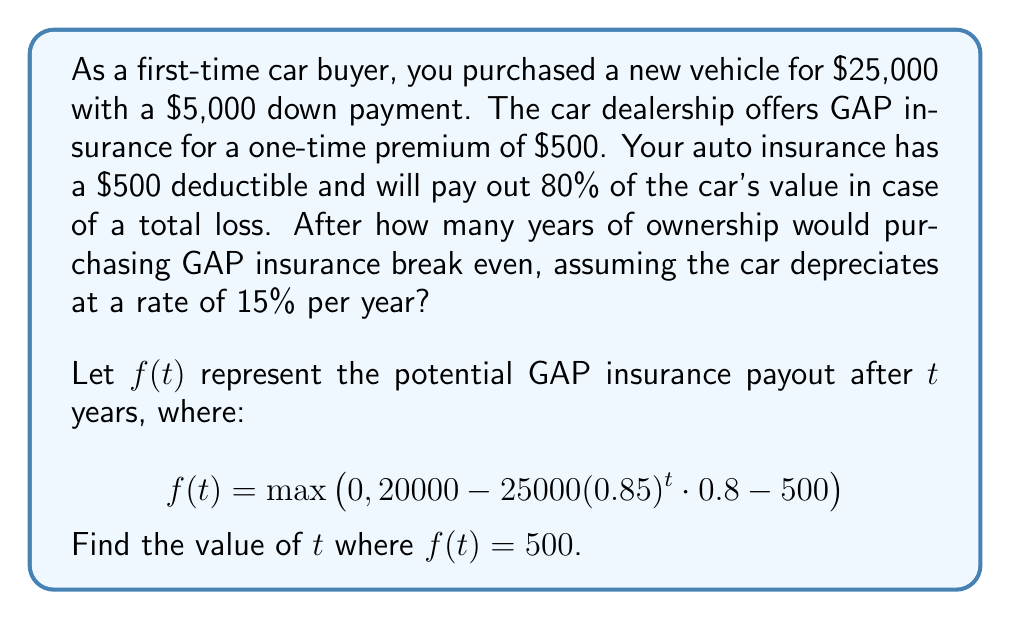Provide a solution to this math problem. Let's break this down step-by-step:

1) The initial loan amount is $25,000 - $5,000 = $20,000.

2) The car's value after $t$ years is $25000(0.85)^t$.

3) In case of a total loss, the insurance would pay:
   $25000(0.85)^t \cdot 0.8 - 500$ (80% of the car's value minus the deductible)

4) The GAP insurance would cover the difference between the loan amount and the insurance payout:
   $f(t) = 20000 - (25000(0.85)^t \cdot 0.8 - 500)$
   
5) We're looking for when this equals the GAP premium of $500:
   $500 = 20000 - (25000(0.85)^t \cdot 0.8 - 500)$

6) Simplifying:
   $0 = 19000 - 25000(0.85)^t \cdot 0.8$
   $19000 = 20000(0.85)^t$
   $0.95 = (0.85)^t$

7) Taking the natural log of both sides:
   $\ln(0.95) = t \cdot \ln(0.85)$

8) Solving for $t$:
   $t = \frac{\ln(0.95)}{\ln(0.85)} \approx 0.3404$

9) This is approximately 4.1 months or 0.34 years.
Answer: $t \approx 0.34$ years 